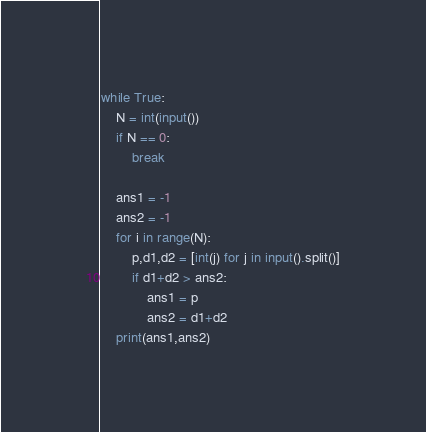Convert code to text. <code><loc_0><loc_0><loc_500><loc_500><_Python_>while True:
    N = int(input())
    if N == 0:
        break

    ans1 = -1
    ans2 = -1
    for i in range(N):
        p,d1,d2 = [int(j) for j in input().split()]
        if d1+d2 > ans2:
            ans1 = p
            ans2 = d1+d2
    print(ans1,ans2)
</code> 